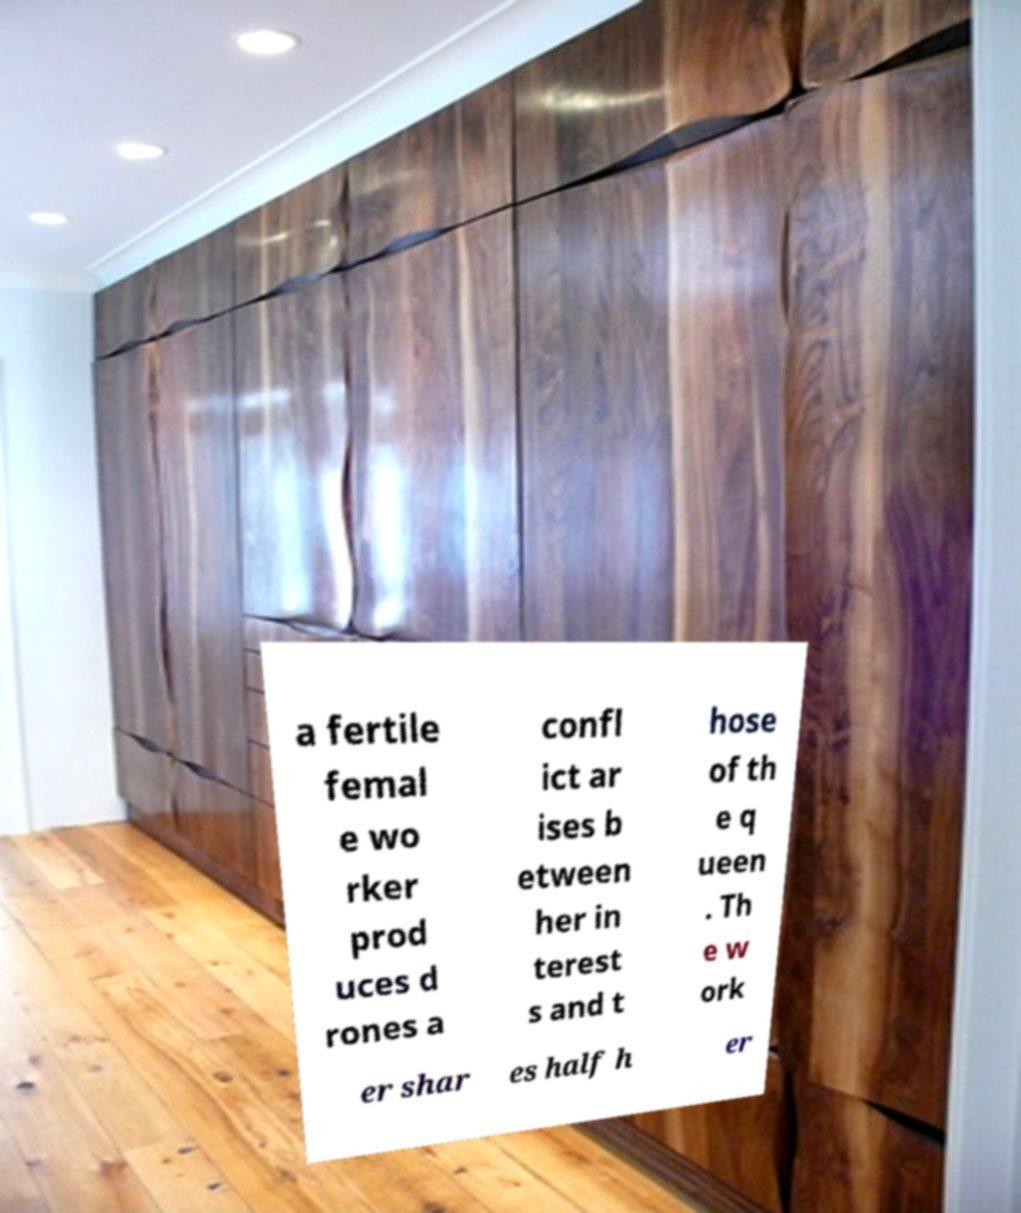Please read and relay the text visible in this image. What does it say? a fertile femal e wo rker prod uces d rones a confl ict ar ises b etween her in terest s and t hose of th e q ueen . Th e w ork er shar es half h er 